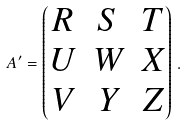Convert formula to latex. <formula><loc_0><loc_0><loc_500><loc_500>A ^ { \prime } = \begin{pmatrix} R & S & T \\ U & W & X \\ V & Y & Z \end{pmatrix} \, .</formula> 